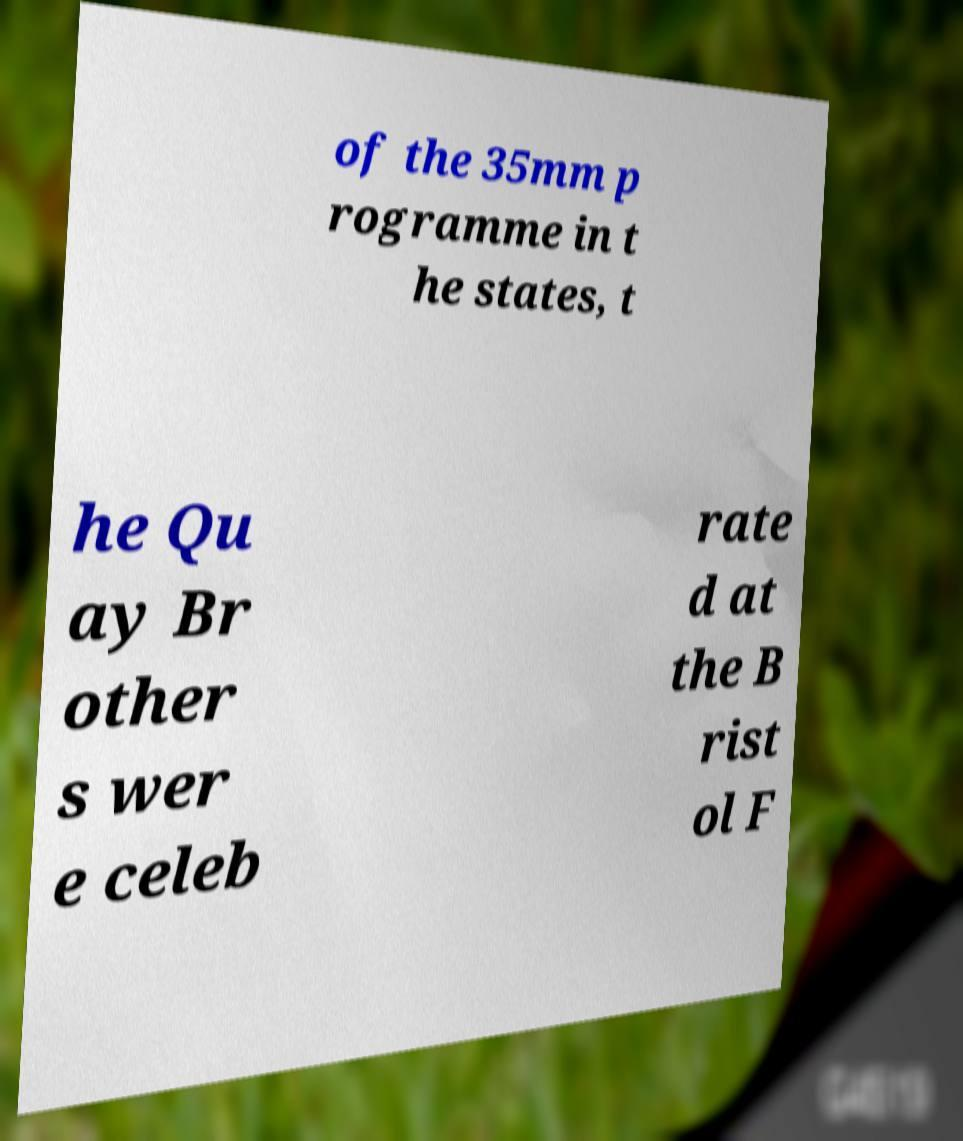Please identify and transcribe the text found in this image. of the 35mm p rogramme in t he states, t he Qu ay Br other s wer e celeb rate d at the B rist ol F 